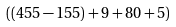<formula> <loc_0><loc_0><loc_500><loc_500>( ( 4 5 5 - 1 5 5 ) + 9 + 8 0 + 5 )</formula> 